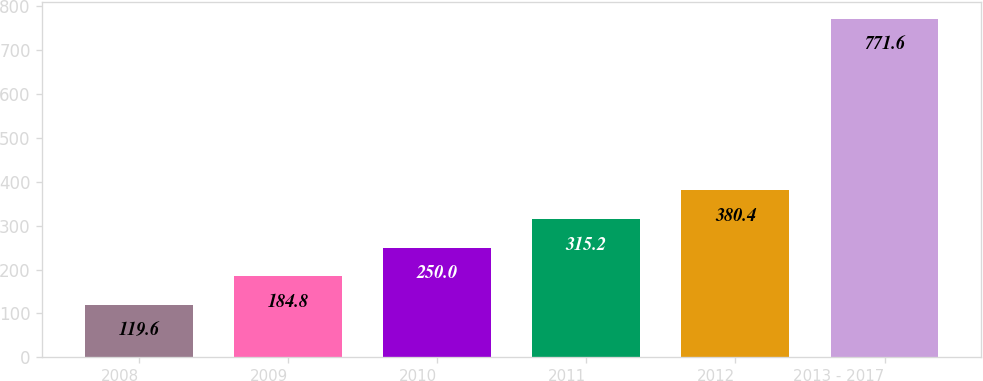<chart> <loc_0><loc_0><loc_500><loc_500><bar_chart><fcel>2008<fcel>2009<fcel>2010<fcel>2011<fcel>2012<fcel>2013 - 2017<nl><fcel>119.6<fcel>184.8<fcel>250<fcel>315.2<fcel>380.4<fcel>771.6<nl></chart> 